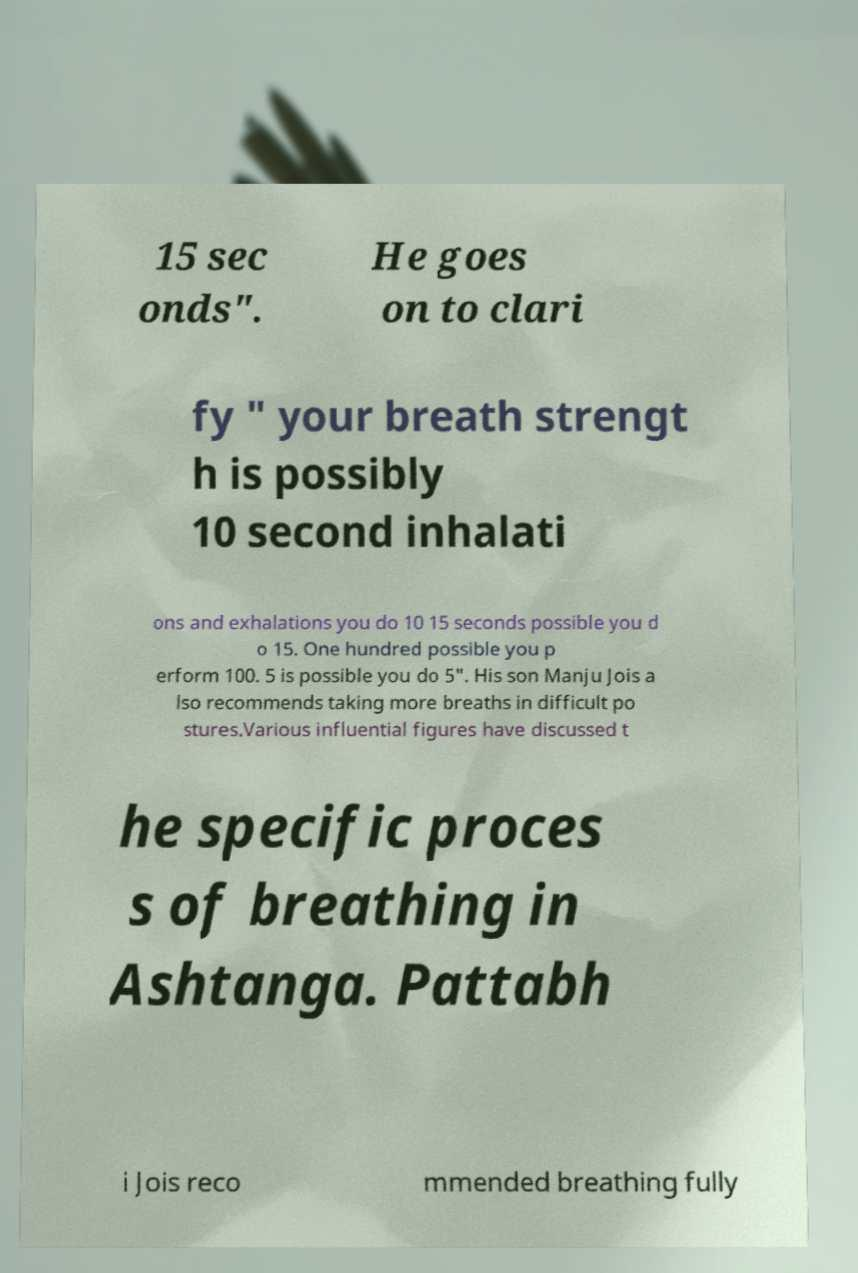What messages or text are displayed in this image? I need them in a readable, typed format. 15 sec onds". He goes on to clari fy " your breath strengt h is possibly 10 second inhalati ons and exhalations you do 10 15 seconds possible you d o 15. One hundred possible you p erform 100. 5 is possible you do 5". His son Manju Jois a lso recommends taking more breaths in difficult po stures.Various influential figures have discussed t he specific proces s of breathing in Ashtanga. Pattabh i Jois reco mmended breathing fully 